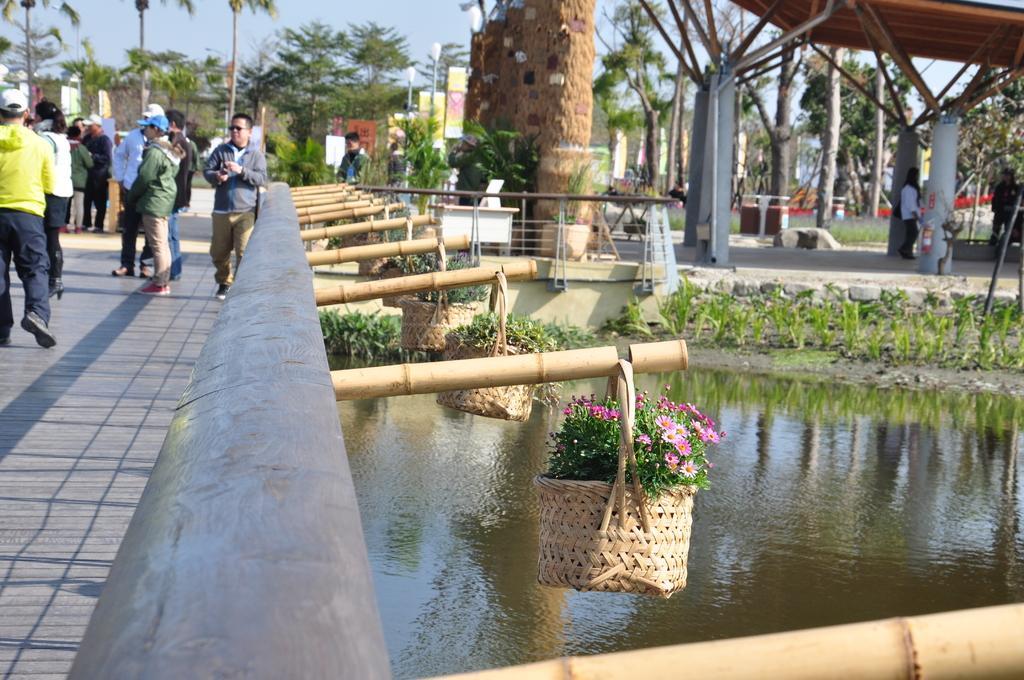In one or two sentences, can you explain what this image depicts? In this image we can see baskets with flowers, water, plants, trees, open shed and people. 